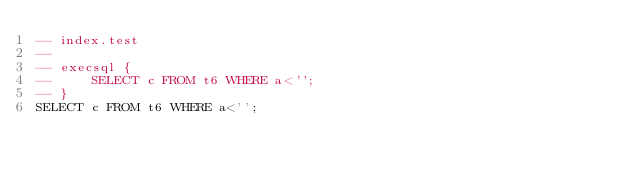Convert code to text. <code><loc_0><loc_0><loc_500><loc_500><_SQL_>-- index.test
-- 
-- execsql {
--     SELECT c FROM t6 WHERE a<'';
-- }
SELECT c FROM t6 WHERE a<'';</code> 